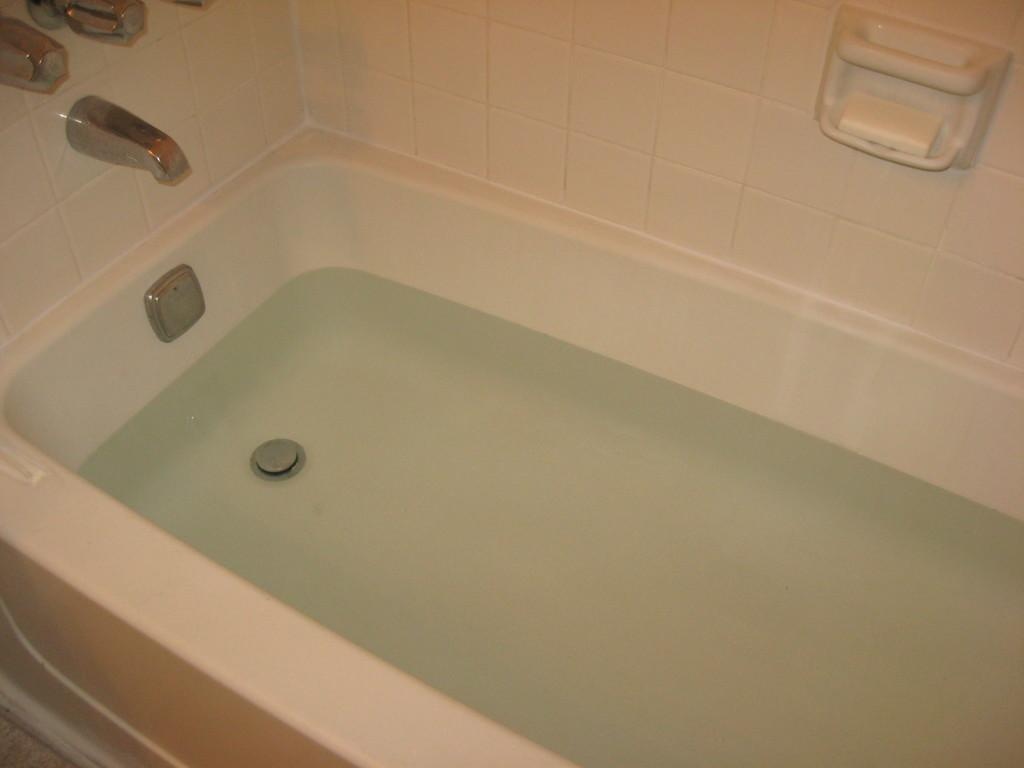What can be seen in the image that contains water? There is a bathtub with water in the image. What type of material covers the wall in the image? The wall has tiles. How is water added to the bathtub in the image? There is a tap in the image for adding water. Where is the soap stored in the image? There is a soap holder in the image. What type of vegetable is being washed in the bathtub in the image? There is no vegetable present in the image; it only shows a bathtub with water. 